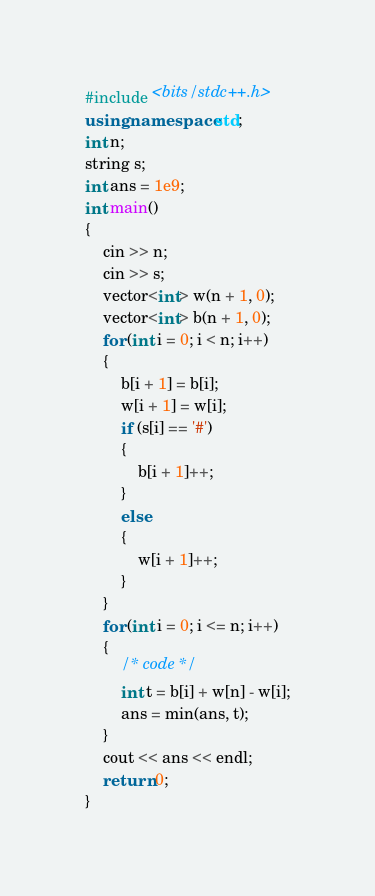Convert code to text. <code><loc_0><loc_0><loc_500><loc_500><_C++_>#include <bits/stdc++.h>
using namespace std;
int n;
string s;
int ans = 1e9;
int main()
{
    cin >> n;
    cin >> s;
    vector<int> w(n + 1, 0);
    vector<int> b(n + 1, 0);
    for (int i = 0; i < n; i++)
    {
        b[i + 1] = b[i];
        w[i + 1] = w[i];
        if (s[i] == '#')
        {
            b[i + 1]++;
        }
        else
        {
            w[i + 1]++;
        }
    }
    for (int i = 0; i <= n; i++)
    {
        /* code */
        int t = b[i] + w[n] - w[i];
        ans = min(ans, t);
    }
    cout << ans << endl;
    return 0;
}</code> 